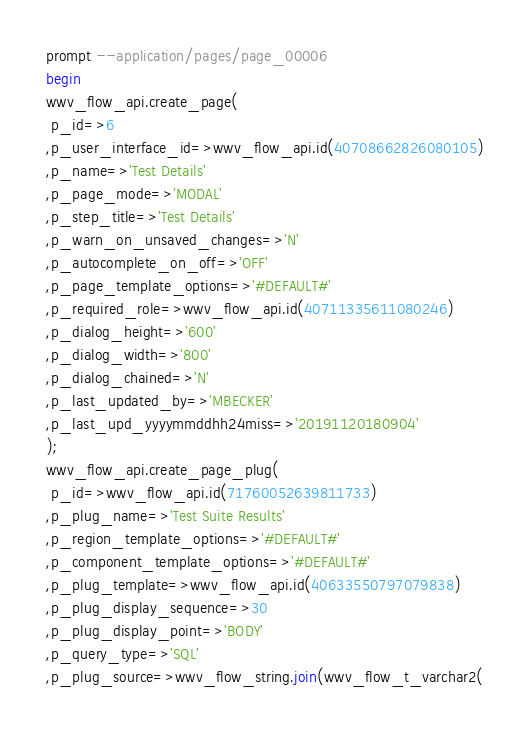Convert code to text. <code><loc_0><loc_0><loc_500><loc_500><_SQL_>prompt --application/pages/page_00006
begin
wwv_flow_api.create_page(
 p_id=>6
,p_user_interface_id=>wwv_flow_api.id(40708662826080105)
,p_name=>'Test Details'
,p_page_mode=>'MODAL'
,p_step_title=>'Test Details'
,p_warn_on_unsaved_changes=>'N'
,p_autocomplete_on_off=>'OFF'
,p_page_template_options=>'#DEFAULT#'
,p_required_role=>wwv_flow_api.id(40711335611080246)
,p_dialog_height=>'600'
,p_dialog_width=>'800'
,p_dialog_chained=>'N'
,p_last_updated_by=>'MBECKER'
,p_last_upd_yyyymmddhh24miss=>'20191120180904'
);
wwv_flow_api.create_page_plug(
 p_id=>wwv_flow_api.id(71760052639811733)
,p_plug_name=>'Test Suite Results'
,p_region_template_options=>'#DEFAULT#'
,p_component_template_options=>'#DEFAULT#'
,p_plug_template=>wwv_flow_api.id(40633550797079838)
,p_plug_display_sequence=>30
,p_plug_display_point=>'BODY'
,p_query_type=>'SQL'
,p_plug_source=>wwv_flow_string.join(wwv_flow_t_varchar2(</code> 